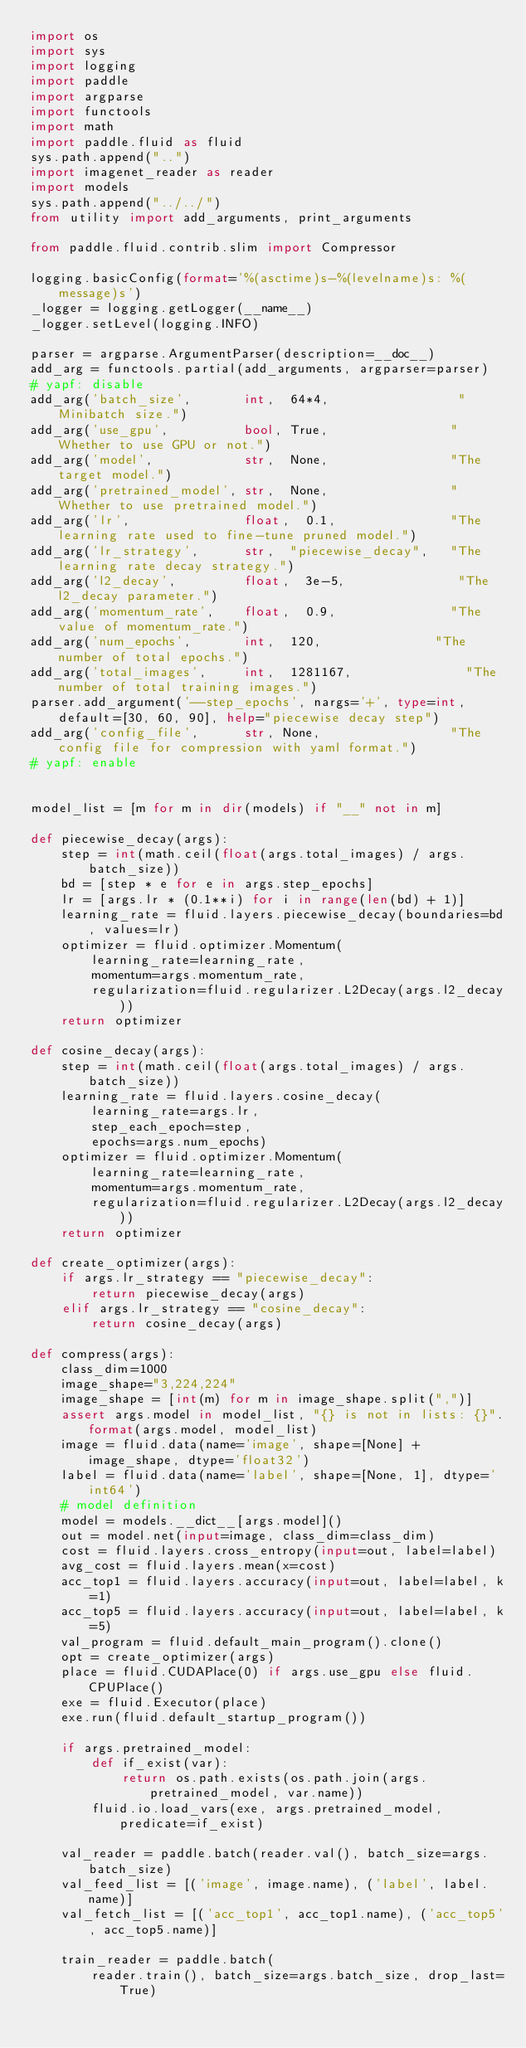Convert code to text. <code><loc_0><loc_0><loc_500><loc_500><_Python_>import os
import sys
import logging
import paddle
import argparse
import functools
import math
import paddle.fluid as fluid
sys.path.append("..")
import imagenet_reader as reader
import models
sys.path.append("../../")
from utility import add_arguments, print_arguments

from paddle.fluid.contrib.slim import Compressor

logging.basicConfig(format='%(asctime)s-%(levelname)s: %(message)s')
_logger = logging.getLogger(__name__)
_logger.setLevel(logging.INFO)

parser = argparse.ArgumentParser(description=__doc__)
add_arg = functools.partial(add_arguments, argparser=parser)
# yapf: disable
add_arg('batch_size',       int,  64*4,                 "Minibatch size.")
add_arg('use_gpu',          bool, True,                "Whether to use GPU or not.")
add_arg('model',            str,  None,                "The target model.")
add_arg('pretrained_model', str,  None,                "Whether to use pretrained model.")
add_arg('lr',               float,  0.1,               "The learning rate used to fine-tune pruned model.")
add_arg('lr_strategy',      str,  "piecewise_decay",   "The learning rate decay strategy.")
add_arg('l2_decay',         float,  3e-5,               "The l2_decay parameter.")
add_arg('momentum_rate',    float,  0.9,               "The value of momentum_rate.")
add_arg('num_epochs',       int,  120,               "The number of total epochs.")
add_arg('total_images',     int,  1281167,               "The number of total training images.")
parser.add_argument('--step_epochs', nargs='+', type=int, default=[30, 60, 90], help="piecewise decay step")
add_arg('config_file',      str, None,                 "The config file for compression with yaml format.")
# yapf: enable


model_list = [m for m in dir(models) if "__" not in m]

def piecewise_decay(args):
    step = int(math.ceil(float(args.total_images) / args.batch_size))
    bd = [step * e for e in args.step_epochs]
    lr = [args.lr * (0.1**i) for i in range(len(bd) + 1)]
    learning_rate = fluid.layers.piecewise_decay(boundaries=bd, values=lr)
    optimizer = fluid.optimizer.Momentum(
        learning_rate=learning_rate,
        momentum=args.momentum_rate,
        regularization=fluid.regularizer.L2Decay(args.l2_decay))
    return optimizer

def cosine_decay(args):
    step = int(math.ceil(float(args.total_images) / args.batch_size))
    learning_rate = fluid.layers.cosine_decay(
        learning_rate=args.lr,
        step_each_epoch=step,
        epochs=args.num_epochs)
    optimizer = fluid.optimizer.Momentum(
        learning_rate=learning_rate,
        momentum=args.momentum_rate,
        regularization=fluid.regularizer.L2Decay(args.l2_decay))
    return optimizer

def create_optimizer(args):
    if args.lr_strategy == "piecewise_decay":
        return piecewise_decay(args)
    elif args.lr_strategy == "cosine_decay":
        return cosine_decay(args)

def compress(args):
    class_dim=1000
    image_shape="3,224,224"
    image_shape = [int(m) for m in image_shape.split(",")]
    assert args.model in model_list, "{} is not in lists: {}".format(args.model, model_list)
    image = fluid.data(name='image', shape=[None] + image_shape, dtype='float32')
    label = fluid.data(name='label', shape=[None, 1], dtype='int64')
    # model definition
    model = models.__dict__[args.model]()
    out = model.net(input=image, class_dim=class_dim)
    cost = fluid.layers.cross_entropy(input=out, label=label)
    avg_cost = fluid.layers.mean(x=cost)
    acc_top1 = fluid.layers.accuracy(input=out, label=label, k=1)
    acc_top5 = fluid.layers.accuracy(input=out, label=label, k=5)
    val_program = fluid.default_main_program().clone()
    opt = create_optimizer(args)
    place = fluid.CUDAPlace(0) if args.use_gpu else fluid.CPUPlace()
    exe = fluid.Executor(place)
    exe.run(fluid.default_startup_program())

    if args.pretrained_model:
        def if_exist(var):
            return os.path.exists(os.path.join(args.pretrained_model, var.name))
        fluid.io.load_vars(exe, args.pretrained_model, predicate=if_exist)

    val_reader = paddle.batch(reader.val(), batch_size=args.batch_size)
    val_feed_list = [('image', image.name), ('label', label.name)]
    val_fetch_list = [('acc_top1', acc_top1.name), ('acc_top5', acc_top5.name)]

    train_reader = paddle.batch(
        reader.train(), batch_size=args.batch_size, drop_last=True)</code> 